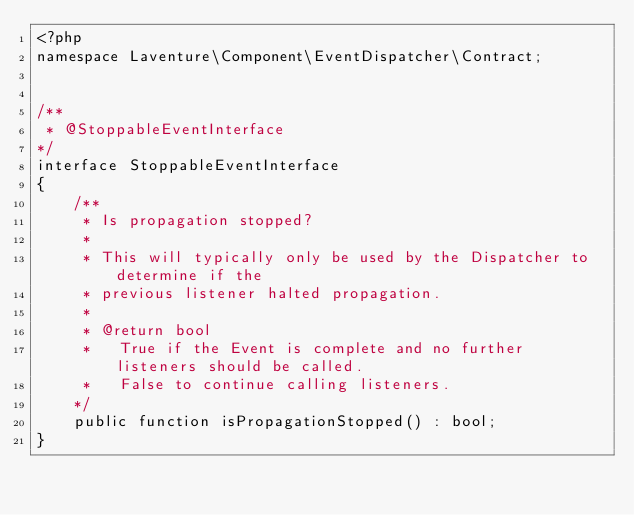<code> <loc_0><loc_0><loc_500><loc_500><_PHP_><?php
namespace Laventure\Component\EventDispatcher\Contract;


/**
 * @StoppableEventInterface
*/
interface StoppableEventInterface
{
    /**
     * Is propagation stopped?
     *
     * This will typically only be used by the Dispatcher to determine if the
     * previous listener halted propagation.
     *
     * @return bool
     *   True if the Event is complete and no further listeners should be called.
     *   False to continue calling listeners.
    */
    public function isPropagationStopped() : bool;
}</code> 